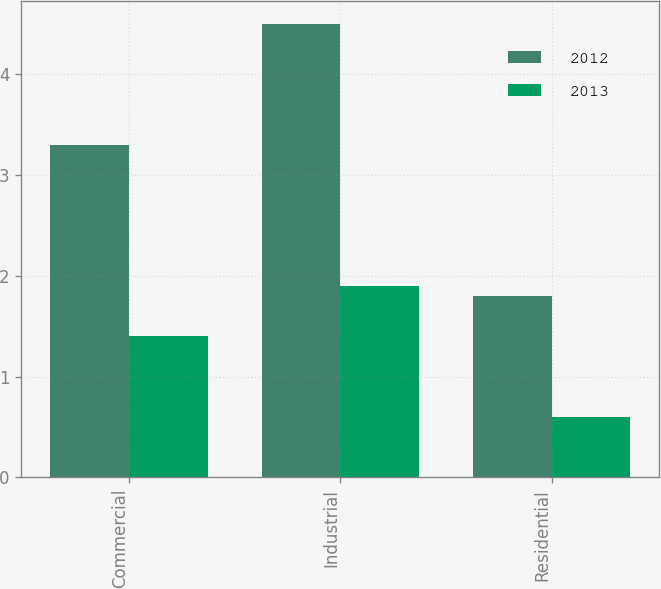Convert chart. <chart><loc_0><loc_0><loc_500><loc_500><stacked_bar_chart><ecel><fcel>Commercial<fcel>Industrial<fcel>Residential<nl><fcel>2012<fcel>3.3<fcel>4.5<fcel>1.8<nl><fcel>2013<fcel>1.4<fcel>1.9<fcel>0.6<nl></chart> 